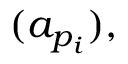Convert formula to latex. <formula><loc_0><loc_0><loc_500><loc_500>( a _ { p _ { i } } ) ,</formula> 